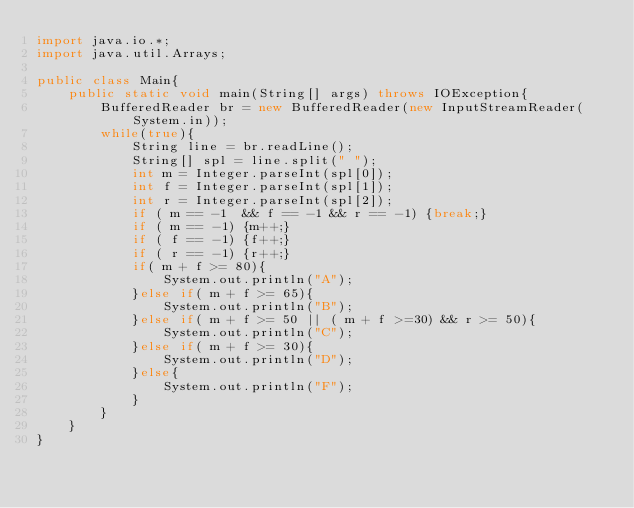Convert code to text. <code><loc_0><loc_0><loc_500><loc_500><_Java_>import java.io.*;
import java.util.Arrays;

public class Main{
	public static void main(String[] args) throws IOException{ 
		BufferedReader br = new BufferedReader(new InputStreamReader(System.in));
		while(true){
			String line = br.readLine();
			String[] spl = line.split(" ");
			int m = Integer.parseInt(spl[0]);
			int f = Integer.parseInt(spl[1]);
			int r = Integer.parseInt(spl[2]);
			if ( m == -1  && f == -1 && r == -1) {break;}
			if ( m == -1) {m++;}
			if ( f == -1) {f++;}
			if ( r == -1) {r++;}
			if( m + f >= 80){
				System.out.println("A");
			}else if( m + f >= 65){
				System.out.println("B");
			}else if( m + f >= 50 || ( m + f >=30) && r >= 50){
				System.out.println("C");
			}else if( m + f >= 30){
				System.out.println("D");
			}else{
				System.out.println("F");
			}
		}
	}
}</code> 